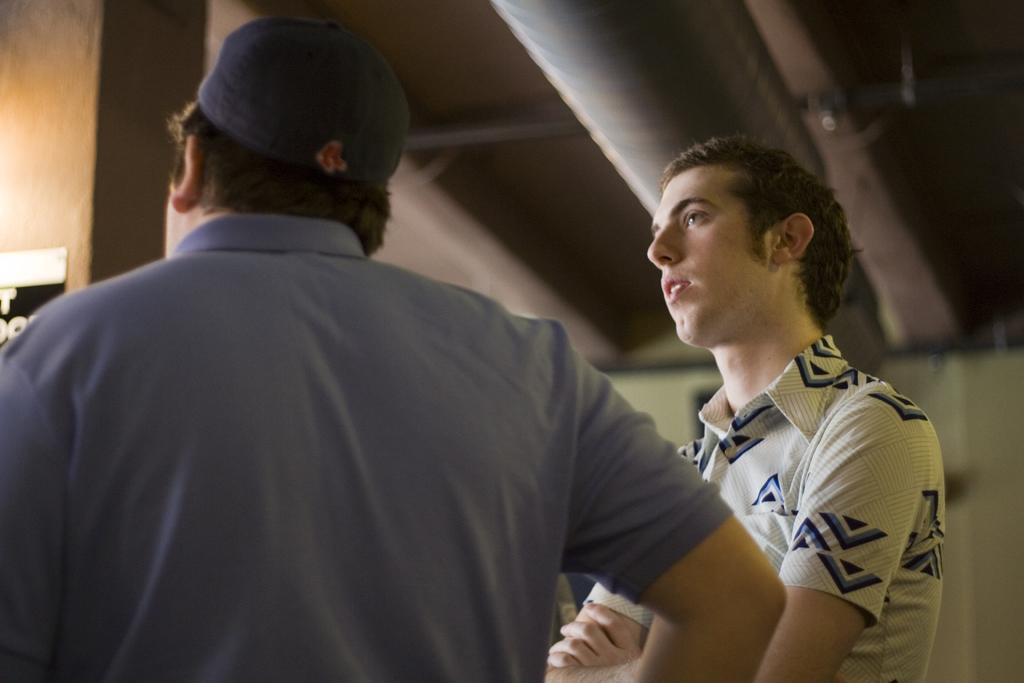How many people are in the image? There are two men in the image. Can you describe the clothing of one of the men? One of the men is wearing a cap. What type of structure is visible in the image? There is a roof visible in the image. What can be seen in the background of the image? There is a wall in the background of the image. What type of map can be seen in the image? There is no map present in the image. Can you describe the teeth of the man wearing the cap? There is no information about the man's teeth in the image. 